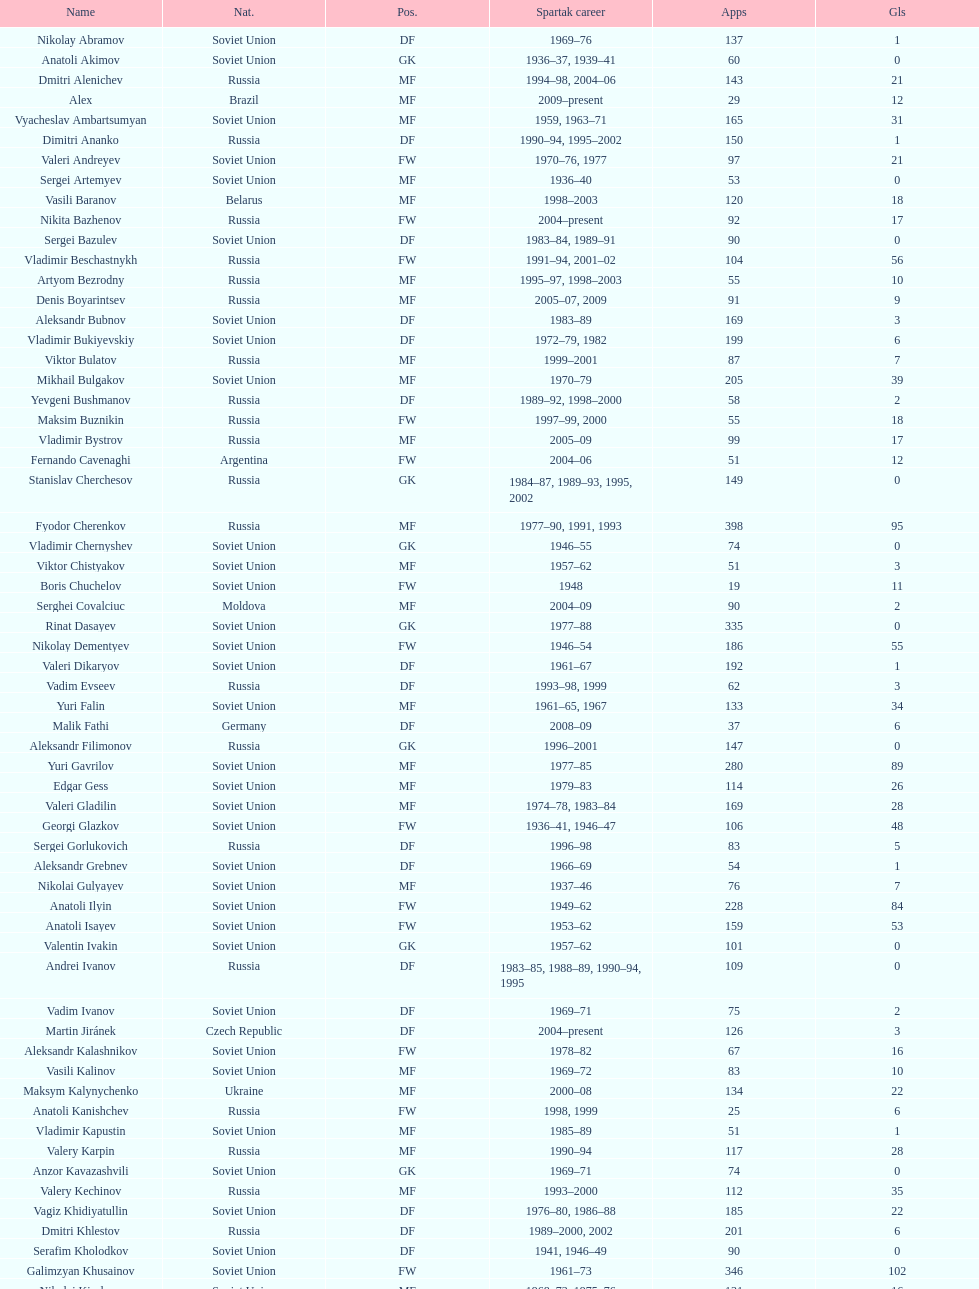Who had the highest number of appearances? Fyodor Cherenkov. 